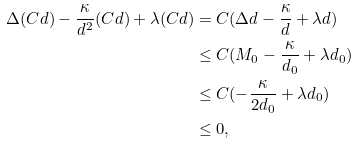<formula> <loc_0><loc_0><loc_500><loc_500>\Delta ( C d ) - \frac { \kappa } { d ^ { 2 } } ( C d ) + \lambda ( C d ) & = C ( \Delta d - \frac { \kappa } { d } + \lambda d ) \\ & \leq C ( M _ { 0 } - \frac { \kappa } { d _ { 0 } } + \lambda d _ { 0 } ) \\ & \leq C ( - \frac { \kappa } { 2 d _ { 0 } } + \lambda d _ { 0 } ) \\ & \leq 0 ,</formula> 